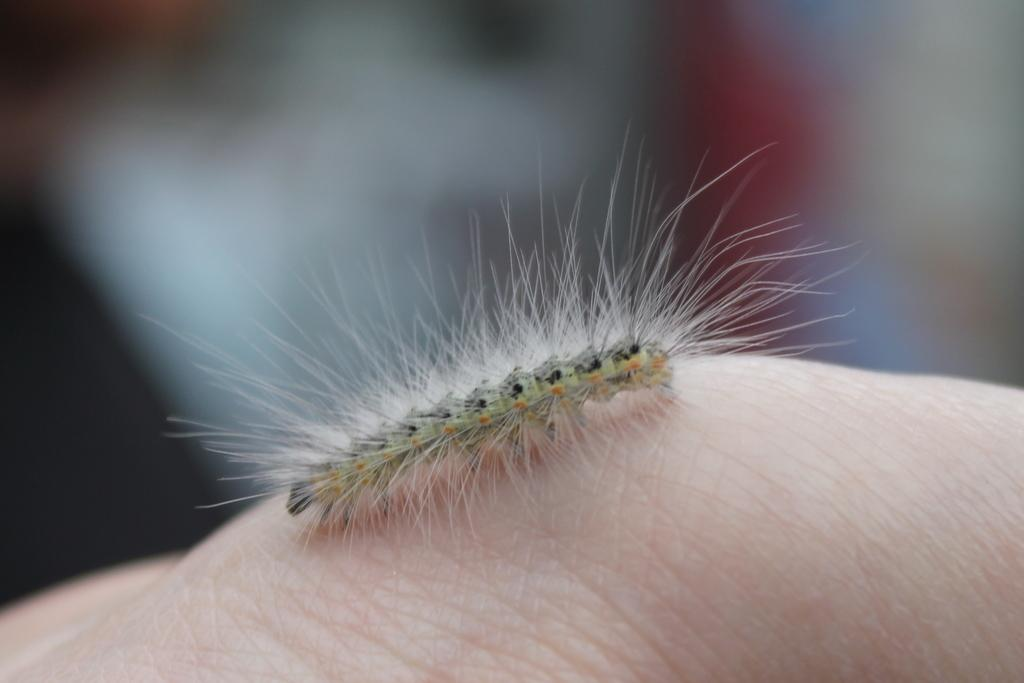What is located in the foreground of the image? There is an insect in the foreground of the image. Where is the insect situated? The insect is on the body of a person. Can you describe the background details be clearly seen in the image? No, the background of the image is blurry. What type of guitar is being played in the background of the image? There is no guitar present in the image; the background is blurry and does not show any musical instruments. 